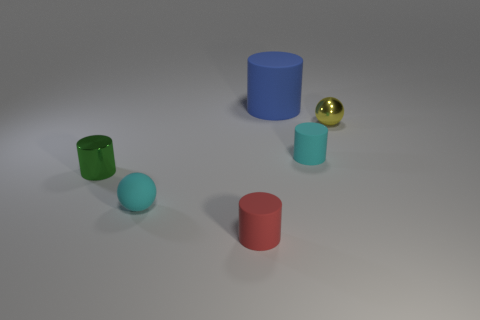Is there any other thing that is the same size as the blue matte cylinder?
Ensure brevity in your answer.  No. Do the tiny metal object that is left of the large blue matte thing and the tiny shiny ball have the same color?
Your answer should be compact. No. Is there a gray cube that has the same material as the large cylinder?
Give a very brief answer. No. Is the number of tiny cyan rubber cylinders on the left side of the large matte cylinder less than the number of tiny red matte things?
Ensure brevity in your answer.  Yes. There is a cyan ball on the left side of the red cylinder; is its size the same as the shiny cylinder?
Provide a succinct answer. Yes. How many small cyan rubber things have the same shape as the large blue thing?
Give a very brief answer. 1. The cyan cylinder that is the same material as the tiny red cylinder is what size?
Provide a succinct answer. Small. Are there an equal number of small green objects that are in front of the tiny red rubber cylinder and tiny gray matte things?
Provide a short and direct response. Yes. Is the color of the large object the same as the rubber ball?
Your answer should be very brief. No. There is a cyan rubber object that is behind the tiny green cylinder; does it have the same shape as the object that is left of the rubber ball?
Provide a short and direct response. Yes. 